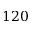Convert formula to latex. <formula><loc_0><loc_0><loc_500><loc_500>1 2 0</formula> 